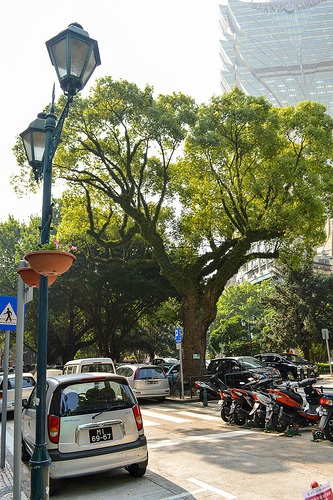<image>
Is the lamp next to the tree? Yes. The lamp is positioned adjacent to the tree, located nearby in the same general area. 